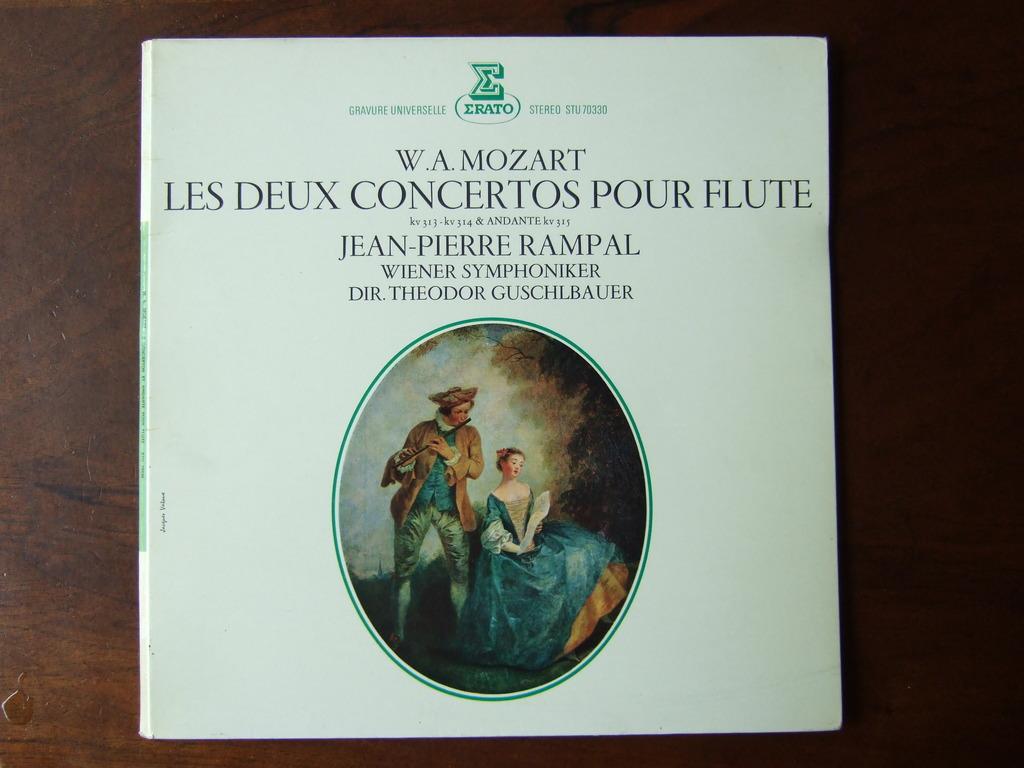Who was the composer of this piece of music?
Give a very brief answer. Mozart. What is the name of this music?
Your response must be concise. Les deux concertos pour flute. 